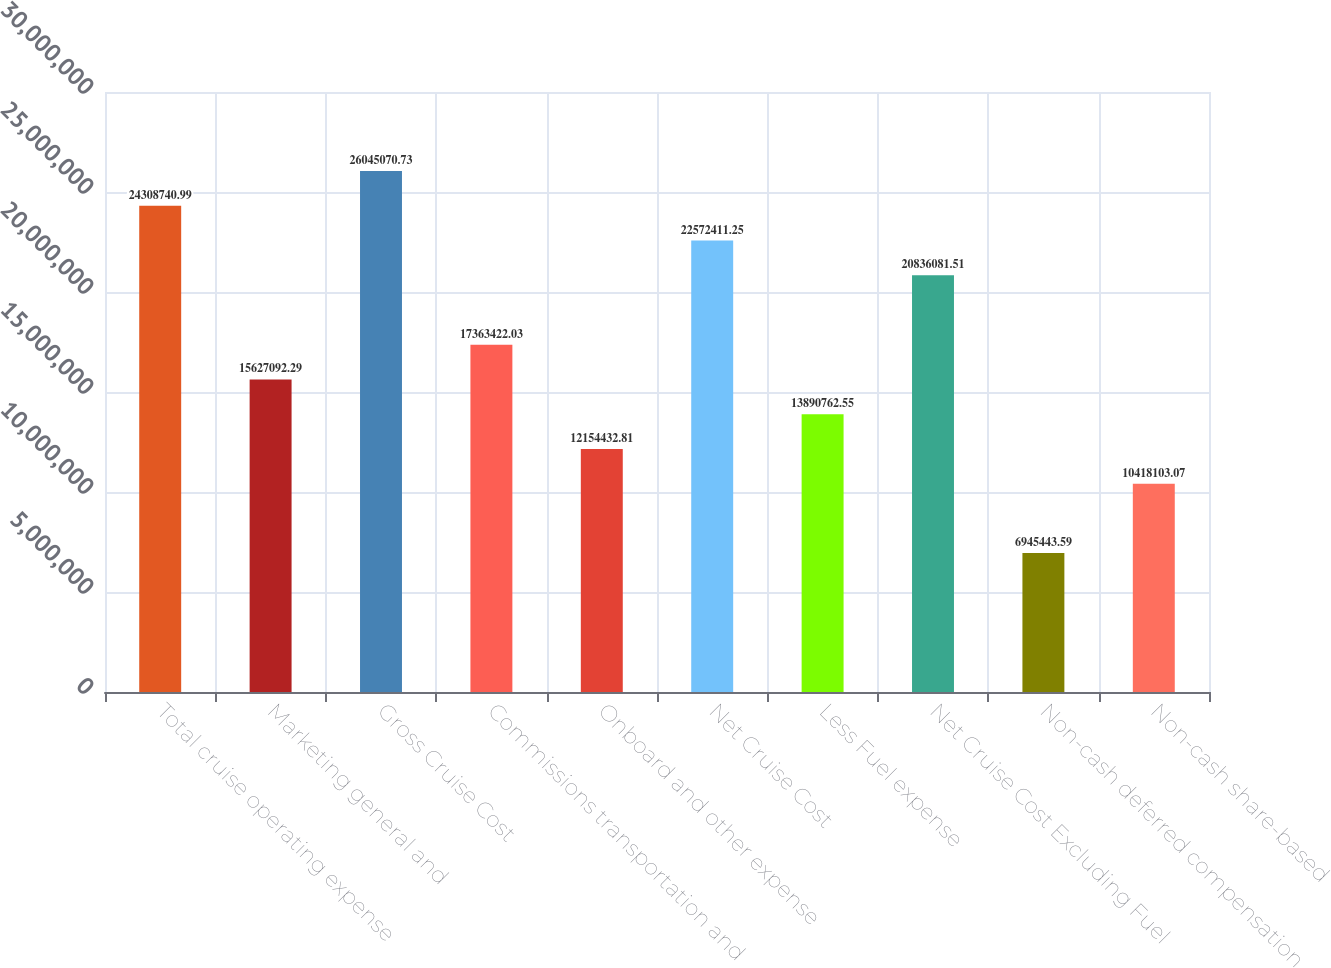Convert chart to OTSL. <chart><loc_0><loc_0><loc_500><loc_500><bar_chart><fcel>Total cruise operating expense<fcel>Marketing general and<fcel>Gross Cruise Cost<fcel>Commissions transportation and<fcel>Onboard and other expense<fcel>Net Cruise Cost<fcel>Less Fuel expense<fcel>Net Cruise Cost Excluding Fuel<fcel>Non-cash deferred compensation<fcel>Non-cash share-based<nl><fcel>2.43087e+07<fcel>1.56271e+07<fcel>2.60451e+07<fcel>1.73634e+07<fcel>1.21544e+07<fcel>2.25724e+07<fcel>1.38908e+07<fcel>2.08361e+07<fcel>6.94544e+06<fcel>1.04181e+07<nl></chart> 